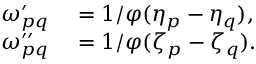Convert formula to latex. <formula><loc_0><loc_0><loc_500><loc_500>\begin{array} { r l } { \omega _ { p q } ^ { \prime } } & = 1 / \varphi ( \eta _ { p } - \eta _ { q } ) , } \\ { \omega _ { p q } ^ { \prime \prime } } & = 1 / \varphi ( \zeta _ { p } - \zeta _ { q } ) . } \end{array}</formula> 